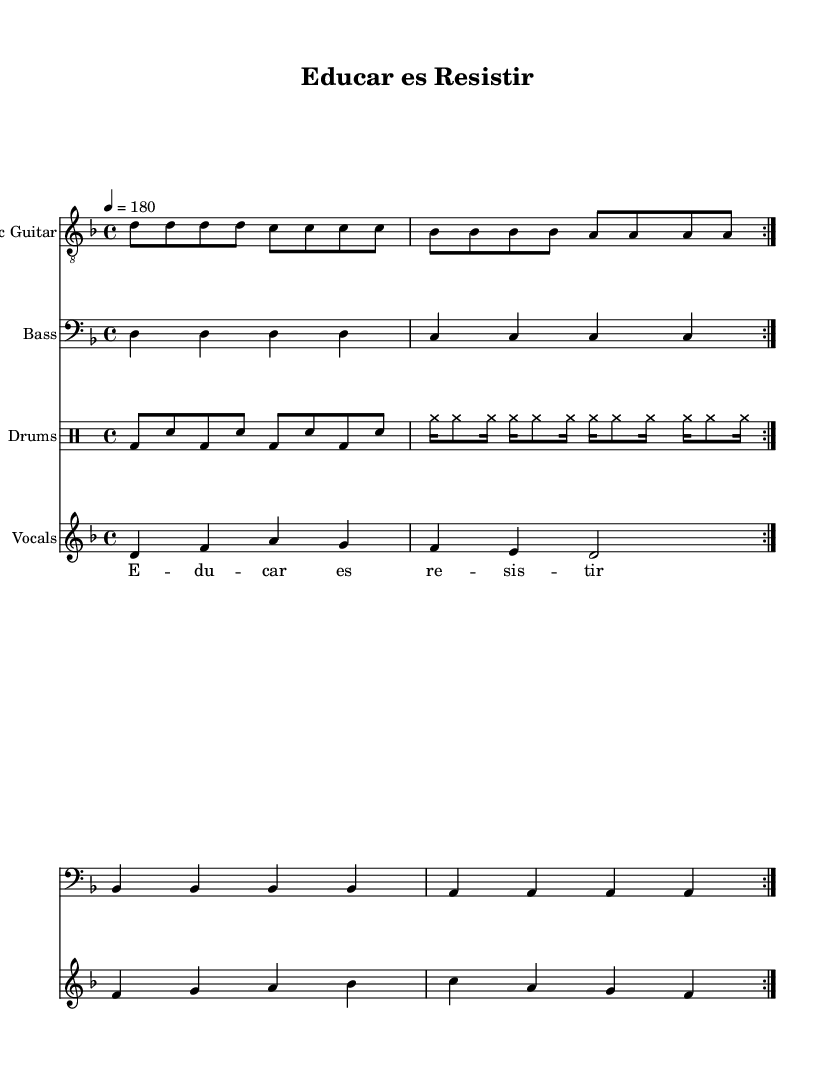What is the key signature of this music? The key signature is D minor, which has one flat (B flat). This can be determined from the key signature indicated at the beginning of the sheet music.
Answer: D minor What is the time signature of this music? The time signature is 4/4, indicating that there are four beats per measure and the quarter note receives one beat. This is visible at the start of the music, right after the key signature.
Answer: 4/4 What is the tempo marking given in this piece? The tempo marking is 180 beats per minute, specified right above the music staff. This indicates the speed at which the piece should be played, usually noted as a number.
Answer: 180 How many measures are repeated in the song? The song consists of two measures that are repeated as indicated by the "volta" markings in both electric guitar and bass guitar parts. This is a typical element in punk music for building energy.
Answer: 2 What is the main lyrical theme of this piece? The lyrics convey a message of resistance related to education, as indicated by the phrase "Educar es Resistir" providing insight into the song's focus on education reform and teacher's rights. This theme is central to punk music's ethos of social activism.
Answer: Education reform How many instruments are included in this ensemble? There are four different instruments represented in the ensemble: electric guitar, bass, drums, and vocals. Each instrument has its own staff in the score, denoting their individual parts while contributing to the overall punk sound.
Answer: 4 What type of rhythms are primarily used in the drum part? The drum part features a mix of bass drum (bd) and snare (sn) hits, along with cymbals (cymr) played in quick succession, reflecting the high-energy and driving rhythm typical in punk music. This aggressive drumming style contributes to the urgency of the track.
Answer: High-energy rhythms 